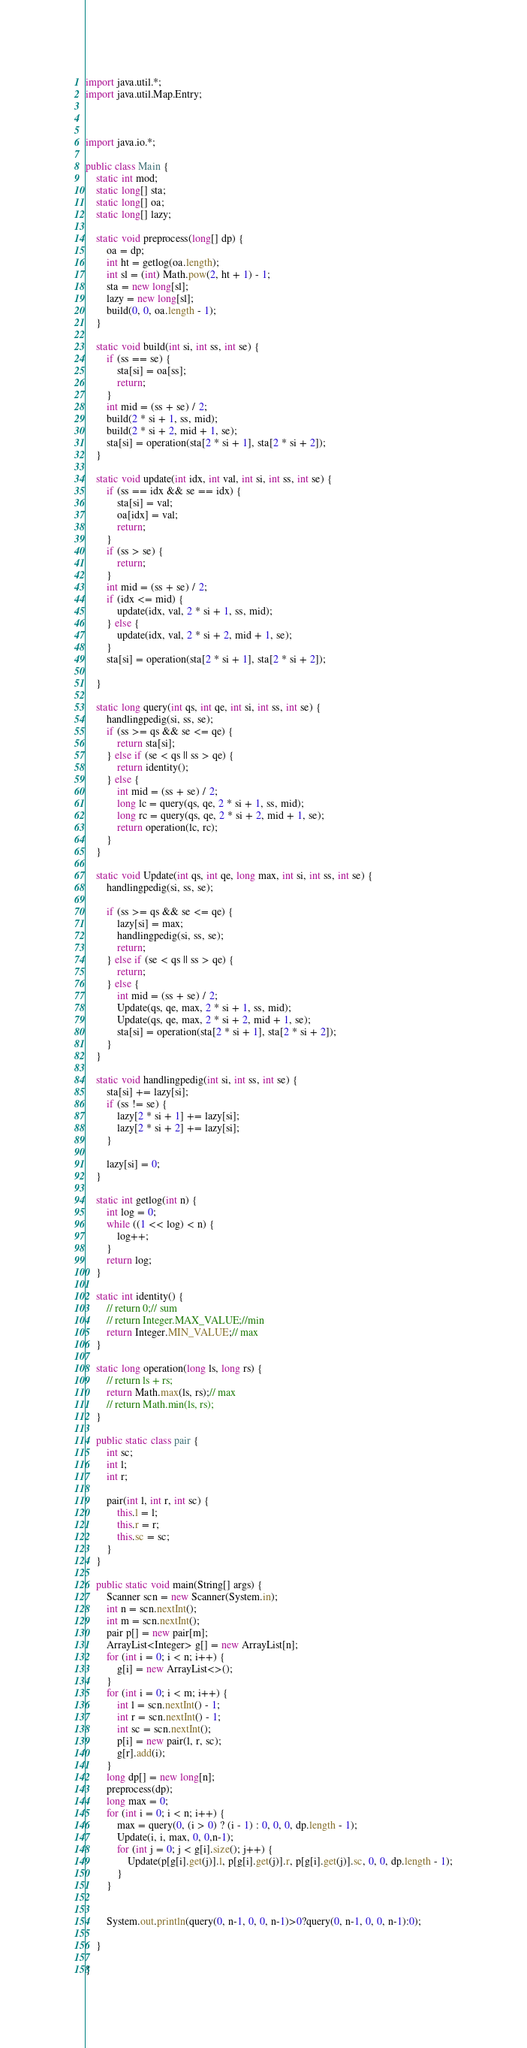<code> <loc_0><loc_0><loc_500><loc_500><_Java_>import java.util.*;
import java.util.Map.Entry;



import java.io.*;

public class Main {
	static int mod;
	static long[] sta;
	static long[] oa;
	static long[] lazy;

	static void preprocess(long[] dp) {
		oa = dp;
		int ht = getlog(oa.length);
		int sl = (int) Math.pow(2, ht + 1) - 1;
		sta = new long[sl];
		lazy = new long[sl];
		build(0, 0, oa.length - 1);
	}

	static void build(int si, int ss, int se) {
		if (ss == se) {
			sta[si] = oa[ss];
			return;
		}
		int mid = (ss + se) / 2;
		build(2 * si + 1, ss, mid);
		build(2 * si + 2, mid + 1, se);
		sta[si] = operation(sta[2 * si + 1], sta[2 * si + 2]);
	}

	static void update(int idx, int val, int si, int ss, int se) {
		if (ss == idx && se == idx) {
			sta[si] = val;
			oa[idx] = val;
			return;
		}
		if (ss > se) {
			return;
		}
		int mid = (ss + se) / 2;
		if (idx <= mid) {
			update(idx, val, 2 * si + 1, ss, mid);
		} else {
			update(idx, val, 2 * si + 2, mid + 1, se);
		}
		sta[si] = operation(sta[2 * si + 1], sta[2 * si + 2]);

	}

	static long query(int qs, int qe, int si, int ss, int se) {
		handlingpedig(si, ss, se);
		if (ss >= qs && se <= qe) {
			return sta[si];
		} else if (se < qs || ss > qe) {
			return identity();
		} else {
			int mid = (ss + se) / 2;
			long lc = query(qs, qe, 2 * si + 1, ss, mid);
			long rc = query(qs, qe, 2 * si + 2, mid + 1, se);
			return operation(lc, rc);
		}
	}

	static void Update(int qs, int qe, long max, int si, int ss, int se) {
		handlingpedig(si, ss, se);

		if (ss >= qs && se <= qe) {
			lazy[si] = max;
			handlingpedig(si, ss, se);
			return;
		} else if (se < qs || ss > qe) {
			return;
		} else {
			int mid = (ss + se) / 2;
			Update(qs, qe, max, 2 * si + 1, ss, mid);
			Update(qs, qe, max, 2 * si + 2, mid + 1, se);
			sta[si] = operation(sta[2 * si + 1], sta[2 * si + 2]);
		}
	}

	static void handlingpedig(int si, int ss, int se) {
		sta[si] += lazy[si];
		if (ss != se) {
			lazy[2 * si + 1] += lazy[si];
			lazy[2 * si + 2] += lazy[si];
		}

		lazy[si] = 0;
	}

	static int getlog(int n) {
		int log = 0;
		while ((1 << log) < n) {
			log++;
		}
		return log;
	}

	static int identity() {
		// return 0;// sum
		// return Integer.MAX_VALUE;//min
		return Integer.MIN_VALUE;// max
	}

	static long operation(long ls, long rs) {
		// return ls + rs;
		return Math.max(ls, rs);// max
		// return Math.min(ls, rs);
	}

	public static class pair {
		int sc;
		int l;
		int r;

		pair(int l, int r, int sc) {
			this.l = l;
			this.r = r;
			this.sc = sc;
		}
	}

	public static void main(String[] args) {
		Scanner scn = new Scanner(System.in);
		int n = scn.nextInt();
		int m = scn.nextInt();
		pair p[] = new pair[m];
		ArrayList<Integer> g[] = new ArrayList[n];
		for (int i = 0; i < n; i++) {
			g[i] = new ArrayList<>();
		}
		for (int i = 0; i < m; i++) {
			int l = scn.nextInt() - 1;
			int r = scn.nextInt() - 1;
			int sc = scn.nextInt();
			p[i] = new pair(l, r, sc);
			g[r].add(i);
		}
		long dp[] = new long[n];
		preprocess(dp);
		long max = 0;
		for (int i = 0; i < n; i++) {
			max = query(0, (i > 0) ? (i - 1) : 0, 0, 0, dp.length - 1);
			Update(i, i, max, 0, 0,n-1);
			for (int j = 0; j < g[i].size(); j++) {
				Update(p[g[i].get(j)].l, p[g[i].get(j)].r, p[g[i].get(j)].sc, 0, 0, dp.length - 1);
			}
		}
		
		
		System.out.println(query(0, n-1, 0, 0, n-1)>0?query(0, n-1, 0, 0, n-1):0);

	}

}</code> 